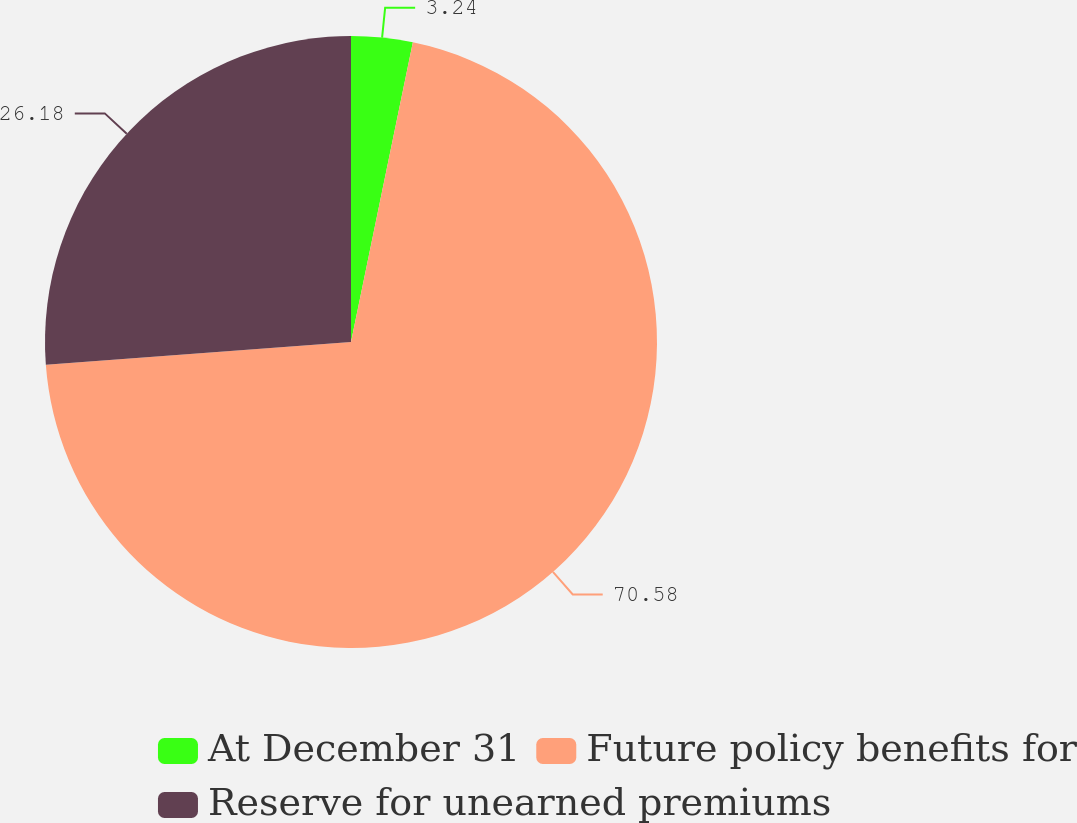Convert chart. <chart><loc_0><loc_0><loc_500><loc_500><pie_chart><fcel>At December 31<fcel>Future policy benefits for<fcel>Reserve for unearned premiums<nl><fcel>3.24%<fcel>70.58%<fcel>26.18%<nl></chart> 